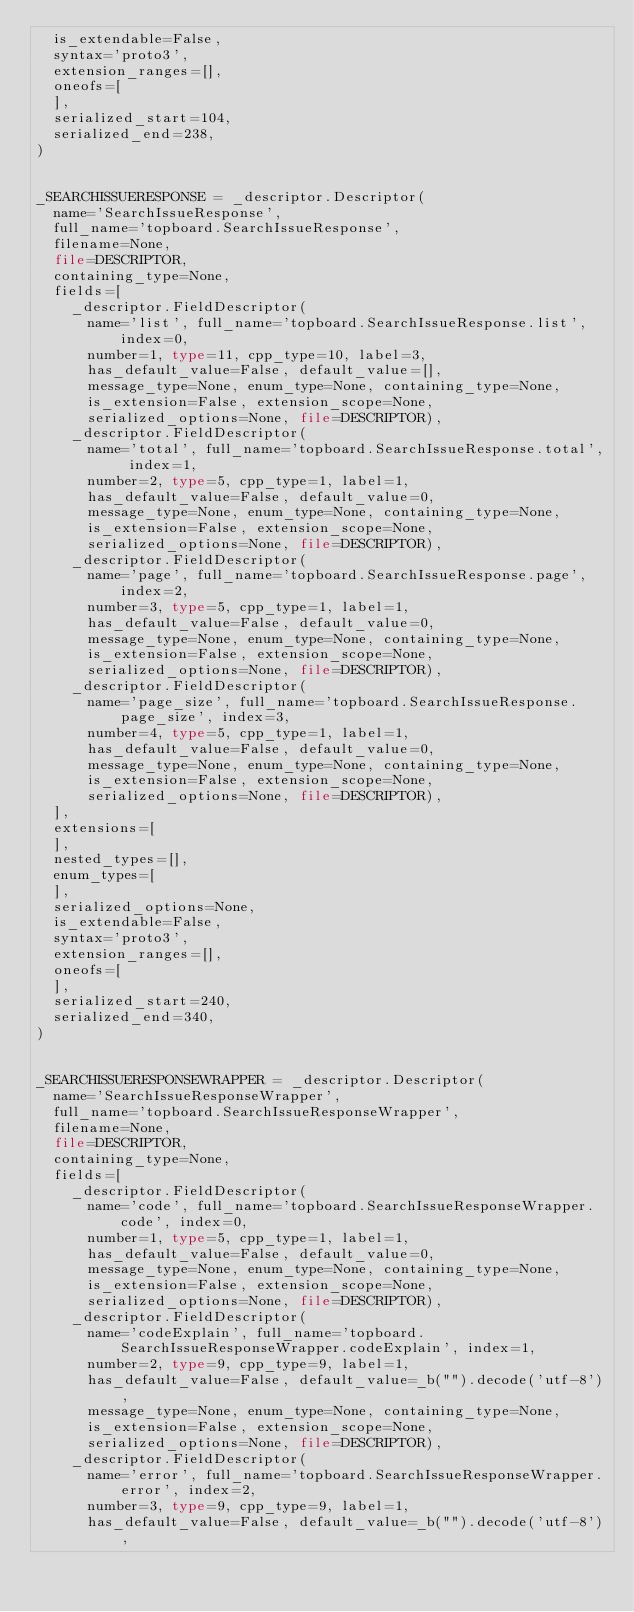<code> <loc_0><loc_0><loc_500><loc_500><_Python_>  is_extendable=False,
  syntax='proto3',
  extension_ranges=[],
  oneofs=[
  ],
  serialized_start=104,
  serialized_end=238,
)


_SEARCHISSUERESPONSE = _descriptor.Descriptor(
  name='SearchIssueResponse',
  full_name='topboard.SearchIssueResponse',
  filename=None,
  file=DESCRIPTOR,
  containing_type=None,
  fields=[
    _descriptor.FieldDescriptor(
      name='list', full_name='topboard.SearchIssueResponse.list', index=0,
      number=1, type=11, cpp_type=10, label=3,
      has_default_value=False, default_value=[],
      message_type=None, enum_type=None, containing_type=None,
      is_extension=False, extension_scope=None,
      serialized_options=None, file=DESCRIPTOR),
    _descriptor.FieldDescriptor(
      name='total', full_name='topboard.SearchIssueResponse.total', index=1,
      number=2, type=5, cpp_type=1, label=1,
      has_default_value=False, default_value=0,
      message_type=None, enum_type=None, containing_type=None,
      is_extension=False, extension_scope=None,
      serialized_options=None, file=DESCRIPTOR),
    _descriptor.FieldDescriptor(
      name='page', full_name='topboard.SearchIssueResponse.page', index=2,
      number=3, type=5, cpp_type=1, label=1,
      has_default_value=False, default_value=0,
      message_type=None, enum_type=None, containing_type=None,
      is_extension=False, extension_scope=None,
      serialized_options=None, file=DESCRIPTOR),
    _descriptor.FieldDescriptor(
      name='page_size', full_name='topboard.SearchIssueResponse.page_size', index=3,
      number=4, type=5, cpp_type=1, label=1,
      has_default_value=False, default_value=0,
      message_type=None, enum_type=None, containing_type=None,
      is_extension=False, extension_scope=None,
      serialized_options=None, file=DESCRIPTOR),
  ],
  extensions=[
  ],
  nested_types=[],
  enum_types=[
  ],
  serialized_options=None,
  is_extendable=False,
  syntax='proto3',
  extension_ranges=[],
  oneofs=[
  ],
  serialized_start=240,
  serialized_end=340,
)


_SEARCHISSUERESPONSEWRAPPER = _descriptor.Descriptor(
  name='SearchIssueResponseWrapper',
  full_name='topboard.SearchIssueResponseWrapper',
  filename=None,
  file=DESCRIPTOR,
  containing_type=None,
  fields=[
    _descriptor.FieldDescriptor(
      name='code', full_name='topboard.SearchIssueResponseWrapper.code', index=0,
      number=1, type=5, cpp_type=1, label=1,
      has_default_value=False, default_value=0,
      message_type=None, enum_type=None, containing_type=None,
      is_extension=False, extension_scope=None,
      serialized_options=None, file=DESCRIPTOR),
    _descriptor.FieldDescriptor(
      name='codeExplain', full_name='topboard.SearchIssueResponseWrapper.codeExplain', index=1,
      number=2, type=9, cpp_type=9, label=1,
      has_default_value=False, default_value=_b("").decode('utf-8'),
      message_type=None, enum_type=None, containing_type=None,
      is_extension=False, extension_scope=None,
      serialized_options=None, file=DESCRIPTOR),
    _descriptor.FieldDescriptor(
      name='error', full_name='topboard.SearchIssueResponseWrapper.error', index=2,
      number=3, type=9, cpp_type=9, label=1,
      has_default_value=False, default_value=_b("").decode('utf-8'),</code> 